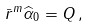Convert formula to latex. <formula><loc_0><loc_0><loc_500><loc_500>\bar { r } ^ { m } \widehat { \alpha } _ { 0 } = Q \, ,</formula> 